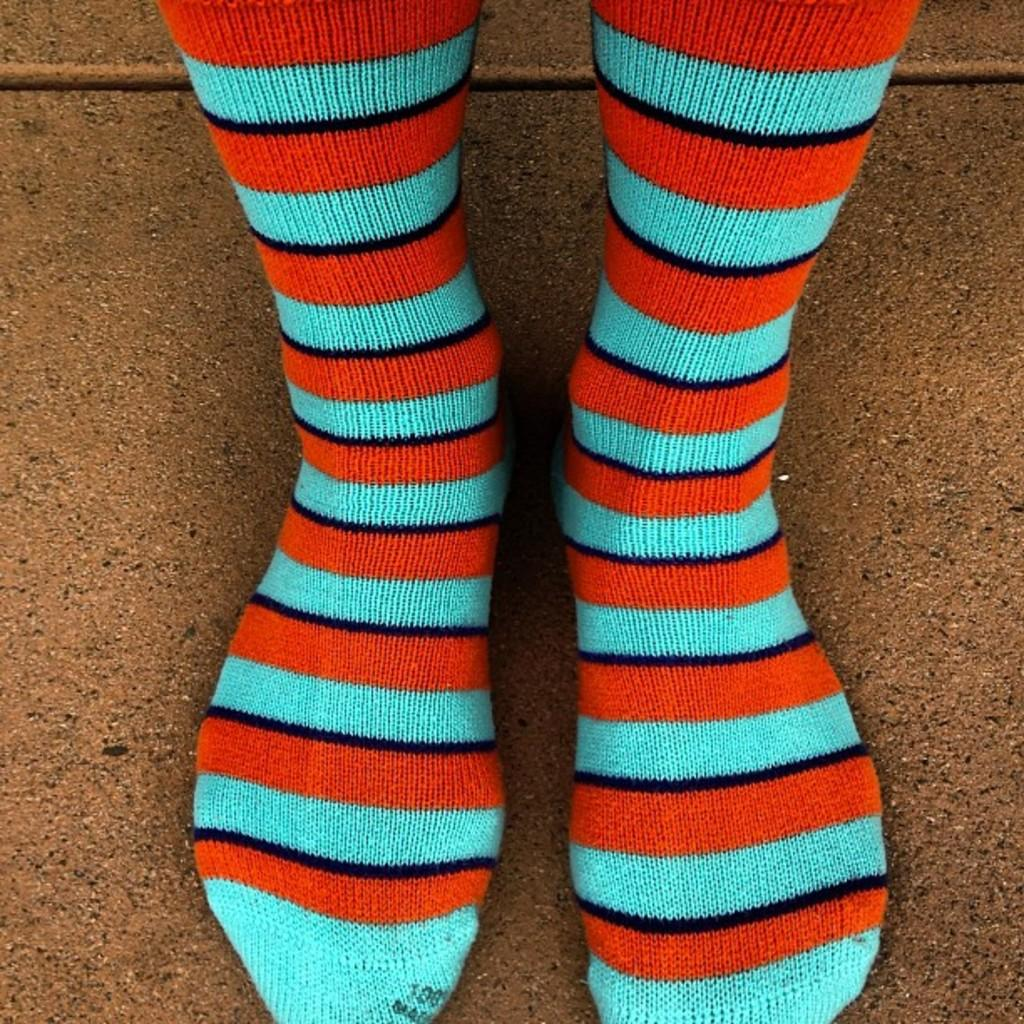Who or what is present in the image? There is a person in the image. What is the person wearing on their feet? The person is wearing socks. Can you describe the color combination of the socks? The socks have a blue, black, and orange color combination. How is the person positioned in the image? The person is standing on the floor with both feet. What type of news can be seen on the socks in the image? There is no news present on the socks in the image; they only have a blue, black, and orange color combination. 